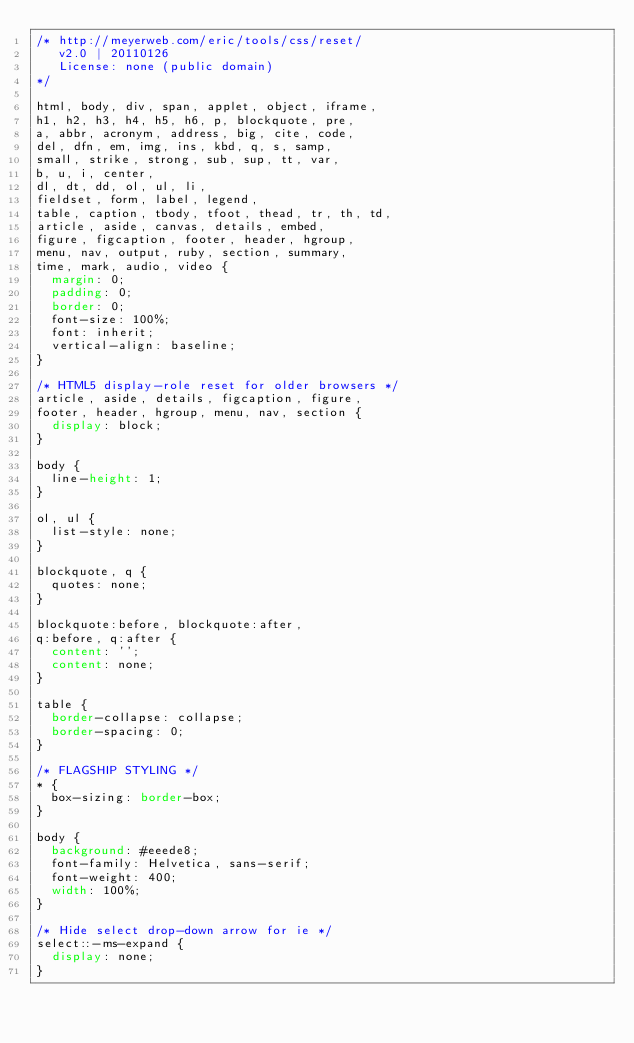<code> <loc_0><loc_0><loc_500><loc_500><_CSS_>/* http://meyerweb.com/eric/tools/css/reset/ 
   v2.0 | 20110126
   License: none (public domain)
*/

html, body, div, span, applet, object, iframe,
h1, h2, h3, h4, h5, h6, p, blockquote, pre,
a, abbr, acronym, address, big, cite, code,
del, dfn, em, img, ins, kbd, q, s, samp,
small, strike, strong, sub, sup, tt, var,
b, u, i, center,
dl, dt, dd, ol, ul, li,
fieldset, form, label, legend,
table, caption, tbody, tfoot, thead, tr, th, td,
article, aside, canvas, details, embed, 
figure, figcaption, footer, header, hgroup, 
menu, nav, output, ruby, section, summary,
time, mark, audio, video {
  margin: 0;
  padding: 0;
  border: 0;
  font-size: 100%;
  font: inherit;
  vertical-align: baseline;
}

/* HTML5 display-role reset for older browsers */
article, aside, details, figcaption, figure, 
footer, header, hgroup, menu, nav, section {
  display: block;
}

body {
  line-height: 1;
}

ol, ul {
  list-style: none;
}

blockquote, q {
  quotes: none;
}

blockquote:before, blockquote:after,
q:before, q:after {
  content: '';
  content: none;
}

table {
  border-collapse: collapse;
  border-spacing: 0;
}

/* FLAGSHIP STYLING */
* {
  box-sizing: border-box;
}

body {
  background: #eeede8;
  font-family: Helvetica, sans-serif;
  font-weight: 400;
  width: 100%;
}

/* Hide select drop-down arrow for ie */
select::-ms-expand {
  display: none;
}</code> 